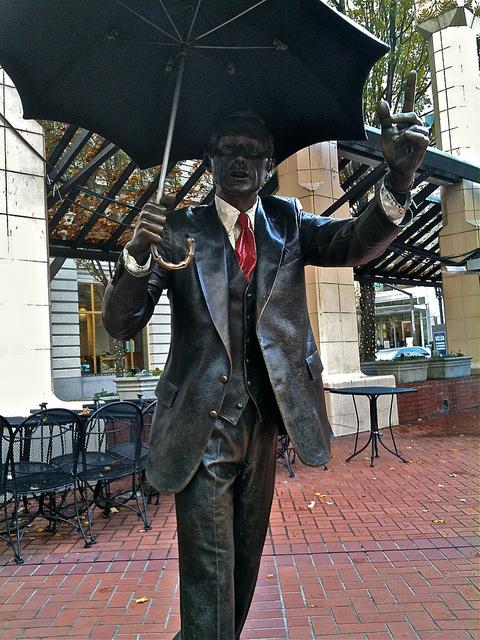What is the statue holding?
Short answer required. Umbrella. What is this art form called?
Short answer required. Statue. What is the man holding?
Short answer required. Umbrella. Is this man black?
Be succinct. Yes. 